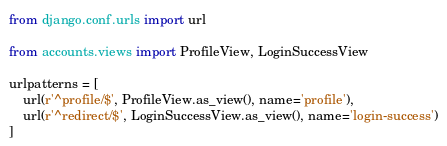Convert code to text. <code><loc_0><loc_0><loc_500><loc_500><_Python_>from django.conf.urls import url

from accounts.views import ProfileView, LoginSuccessView

urlpatterns = [
    url(r'^profile/$', ProfileView.as_view(), name='profile'),
    url(r'^redirect/$', LoginSuccessView.as_view(), name='login-success')
]
</code> 